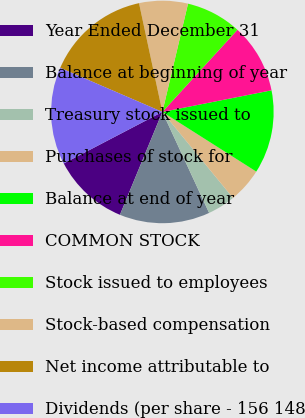Convert chart to OTSL. <chart><loc_0><loc_0><loc_500><loc_500><pie_chart><fcel>Year Ended December 31<fcel>Balance at beginning of year<fcel>Treasury stock issued to<fcel>Purchases of stock for<fcel>Balance at end of year<fcel>COMMON STOCK<fcel>Stock issued to employees<fcel>Stock-based compensation<fcel>Net income attributable to<fcel>Dividends (per share - 156 148<nl><fcel>11.11%<fcel>13.13%<fcel>4.04%<fcel>5.05%<fcel>12.12%<fcel>10.1%<fcel>8.08%<fcel>7.07%<fcel>15.15%<fcel>14.14%<nl></chart> 